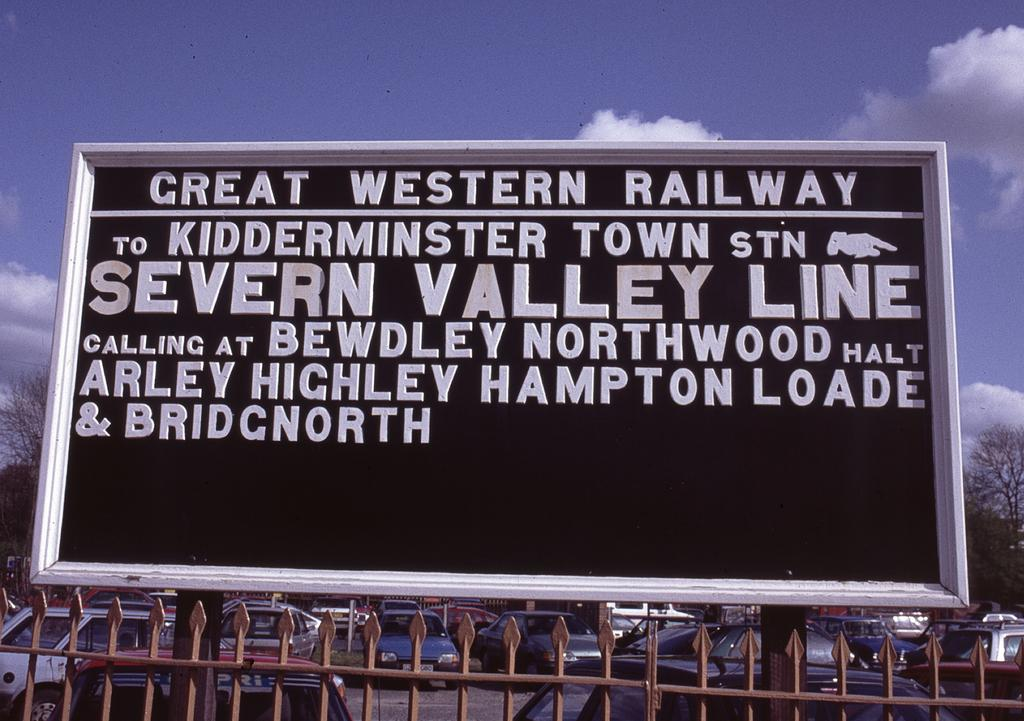<image>
Provide a brief description of the given image. An outdoor sign near a parking lot advertises the Great Western Railway. 